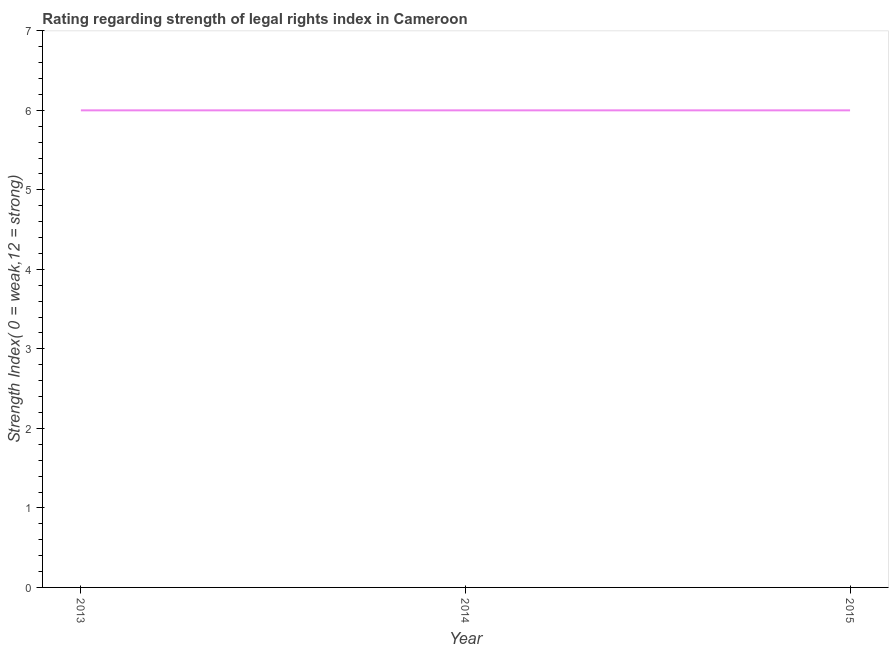What is the strength of legal rights index in 2014?
Offer a very short reply. 6. Across all years, what is the maximum strength of legal rights index?
Provide a short and direct response. 6. What is the sum of the strength of legal rights index?
Ensure brevity in your answer.  18. What is the average strength of legal rights index per year?
Your response must be concise. 6. In how many years, is the strength of legal rights index greater than 2.8 ?
Offer a very short reply. 3. Do a majority of the years between 2013 and 2015 (inclusive) have strength of legal rights index greater than 6 ?
Your answer should be compact. No. What is the ratio of the strength of legal rights index in 2013 to that in 2014?
Your response must be concise. 1. What is the difference between the highest and the second highest strength of legal rights index?
Provide a short and direct response. 0. What is the difference between the highest and the lowest strength of legal rights index?
Provide a succinct answer. 0. In how many years, is the strength of legal rights index greater than the average strength of legal rights index taken over all years?
Provide a short and direct response. 0. Does the strength of legal rights index monotonically increase over the years?
Your answer should be compact. No. How many years are there in the graph?
Make the answer very short. 3. What is the difference between two consecutive major ticks on the Y-axis?
Offer a terse response. 1. Are the values on the major ticks of Y-axis written in scientific E-notation?
Ensure brevity in your answer.  No. Does the graph contain grids?
Your answer should be compact. No. What is the title of the graph?
Ensure brevity in your answer.  Rating regarding strength of legal rights index in Cameroon. What is the label or title of the X-axis?
Your answer should be compact. Year. What is the label or title of the Y-axis?
Your answer should be compact. Strength Index( 0 = weak,12 = strong). What is the difference between the Strength Index( 0 = weak,12 = strong) in 2013 and 2015?
Provide a short and direct response. 0. What is the ratio of the Strength Index( 0 = weak,12 = strong) in 2013 to that in 2014?
Your answer should be very brief. 1. What is the ratio of the Strength Index( 0 = weak,12 = strong) in 2014 to that in 2015?
Offer a very short reply. 1. 